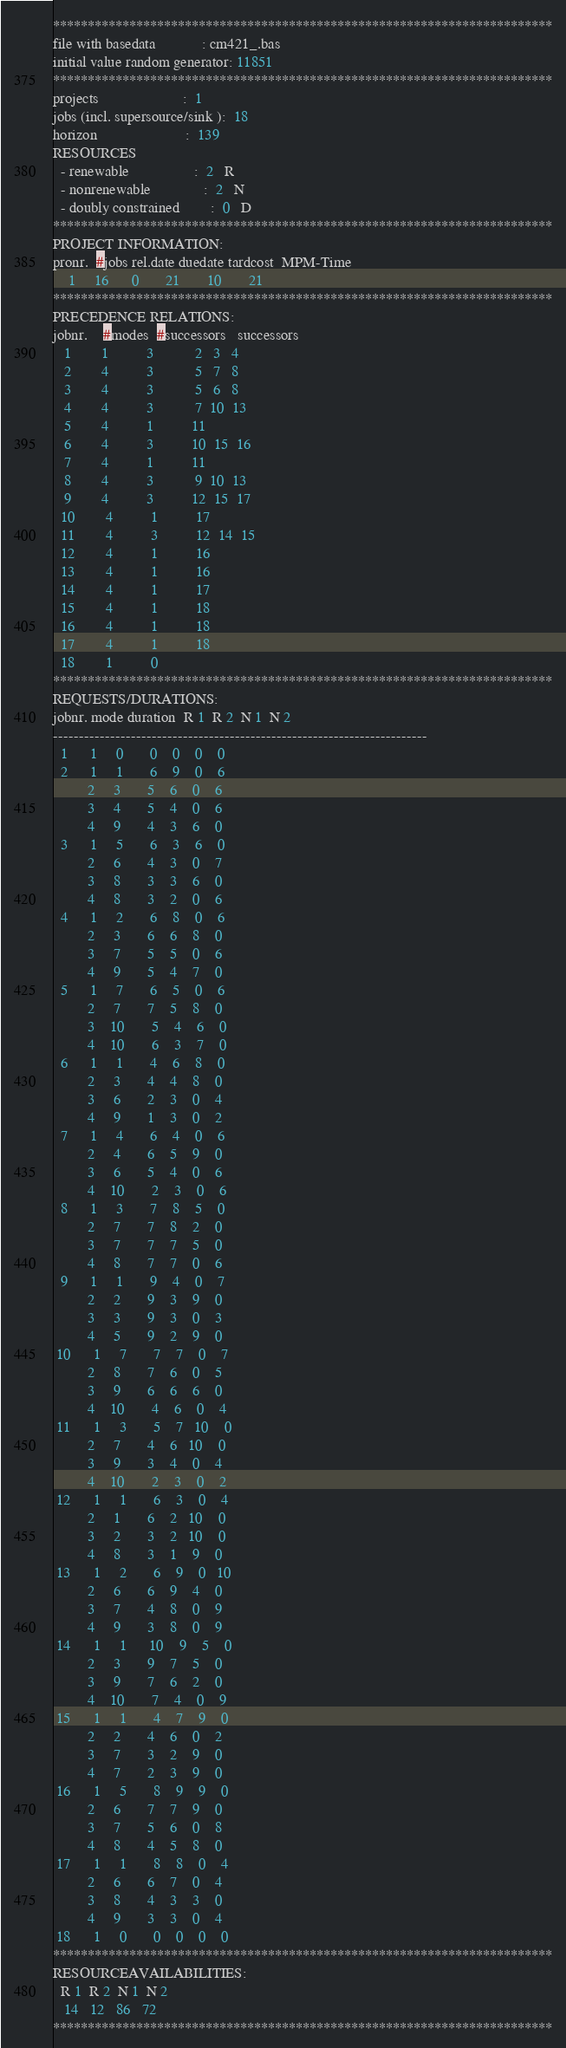<code> <loc_0><loc_0><loc_500><loc_500><_ObjectiveC_>************************************************************************
file with basedata            : cm421_.bas
initial value random generator: 11851
************************************************************************
projects                      :  1
jobs (incl. supersource/sink ):  18
horizon                       :  139
RESOURCES
  - renewable                 :  2   R
  - nonrenewable              :  2   N
  - doubly constrained        :  0   D
************************************************************************
PROJECT INFORMATION:
pronr.  #jobs rel.date duedate tardcost  MPM-Time
    1     16      0       21       10       21
************************************************************************
PRECEDENCE RELATIONS:
jobnr.    #modes  #successors   successors
   1        1          3           2   3   4
   2        4          3           5   7   8
   3        4          3           5   6   8
   4        4          3           7  10  13
   5        4          1          11
   6        4          3          10  15  16
   7        4          1          11
   8        4          3           9  10  13
   9        4          3          12  15  17
  10        4          1          17
  11        4          3          12  14  15
  12        4          1          16
  13        4          1          16
  14        4          1          17
  15        4          1          18
  16        4          1          18
  17        4          1          18
  18        1          0        
************************************************************************
REQUESTS/DURATIONS:
jobnr. mode duration  R 1  R 2  N 1  N 2
------------------------------------------------------------------------
  1      1     0       0    0    0    0
  2      1     1       6    9    0    6
         2     3       5    6    0    6
         3     4       5    4    0    6
         4     9       4    3    6    0
  3      1     5       6    3    6    0
         2     6       4    3    0    7
         3     8       3    3    6    0
         4     8       3    2    0    6
  4      1     2       6    8    0    6
         2     3       6    6    8    0
         3     7       5    5    0    6
         4     9       5    4    7    0
  5      1     7       6    5    0    6
         2     7       7    5    8    0
         3    10       5    4    6    0
         4    10       6    3    7    0
  6      1     1       4    6    8    0
         2     3       4    4    8    0
         3     6       2    3    0    4
         4     9       1    3    0    2
  7      1     4       6    4    0    6
         2     4       6    5    9    0
         3     6       5    4    0    6
         4    10       2    3    0    6
  8      1     3       7    8    5    0
         2     7       7    8    2    0
         3     7       7    7    5    0
         4     8       7    7    0    6
  9      1     1       9    4    0    7
         2     2       9    3    9    0
         3     3       9    3    0    3
         4     5       9    2    9    0
 10      1     7       7    7    0    7
         2     8       7    6    0    5
         3     9       6    6    6    0
         4    10       4    6    0    4
 11      1     3       5    7   10    0
         2     7       4    6   10    0
         3     9       3    4    0    4
         4    10       2    3    0    2
 12      1     1       6    3    0    4
         2     1       6    2   10    0
         3     2       3    2   10    0
         4     8       3    1    9    0
 13      1     2       6    9    0   10
         2     6       6    9    4    0
         3     7       4    8    0    9
         4     9       3    8    0    9
 14      1     1      10    9    5    0
         2     3       9    7    5    0
         3     9       7    6    2    0
         4    10       7    4    0    9
 15      1     1       4    7    9    0
         2     2       4    6    0    2
         3     7       3    2    9    0
         4     7       2    3    9    0
 16      1     5       8    9    9    0
         2     6       7    7    9    0
         3     7       5    6    0    8
         4     8       4    5    8    0
 17      1     1       8    8    0    4
         2     6       6    7    0    4
         3     8       4    3    3    0
         4     9       3    3    0    4
 18      1     0       0    0    0    0
************************************************************************
RESOURCEAVAILABILITIES:
  R 1  R 2  N 1  N 2
   14   12   86   72
************************************************************************
</code> 